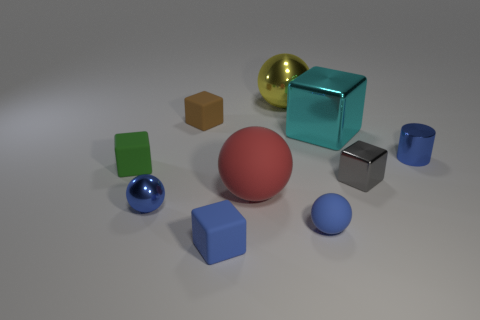Are there more tiny rubber blocks to the left of the small blue metallic ball than big yellow shiny cubes?
Provide a short and direct response. Yes. Are there any cyan shiny things behind the small shiny thing that is to the left of the small block behind the cyan shiny cube?
Give a very brief answer. Yes. Are there any tiny blue balls on the left side of the big yellow object?
Your answer should be very brief. Yes. How many tiny shiny blocks have the same color as the big metallic sphere?
Your response must be concise. 0. There is another ball that is made of the same material as the big yellow ball; what size is it?
Keep it short and to the point. Small. What size is the shiny sphere to the right of the small sphere on the left side of the matte cube in front of the green object?
Keep it short and to the point. Large. There is a cyan object behind the gray thing; what size is it?
Offer a very short reply. Large. What number of gray things are either small metallic blocks or small metal cylinders?
Offer a very short reply. 1. Is there a thing that has the same size as the blue block?
Provide a succinct answer. Yes. What is the material of the brown thing that is the same size as the gray metallic thing?
Your response must be concise. Rubber. 